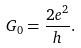Convert formula to latex. <formula><loc_0><loc_0><loc_500><loc_500>G _ { 0 } = \frac { 2 e ^ { 2 } } { h } .</formula> 